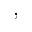<formula> <loc_0><loc_0><loc_500><loc_500>,</formula> 